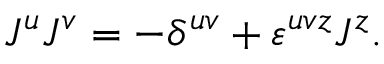<formula> <loc_0><loc_0><loc_500><loc_500>J ^ { u } J ^ { v } = - \delta ^ { u v } + \varepsilon ^ { u v z } J ^ { z } .</formula> 